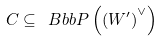<formula> <loc_0><loc_0><loc_500><loc_500>C \subseteq \ B b b { P } \left ( \left ( W ^ { \prime } \right ) ^ { \vee } \right )</formula> 